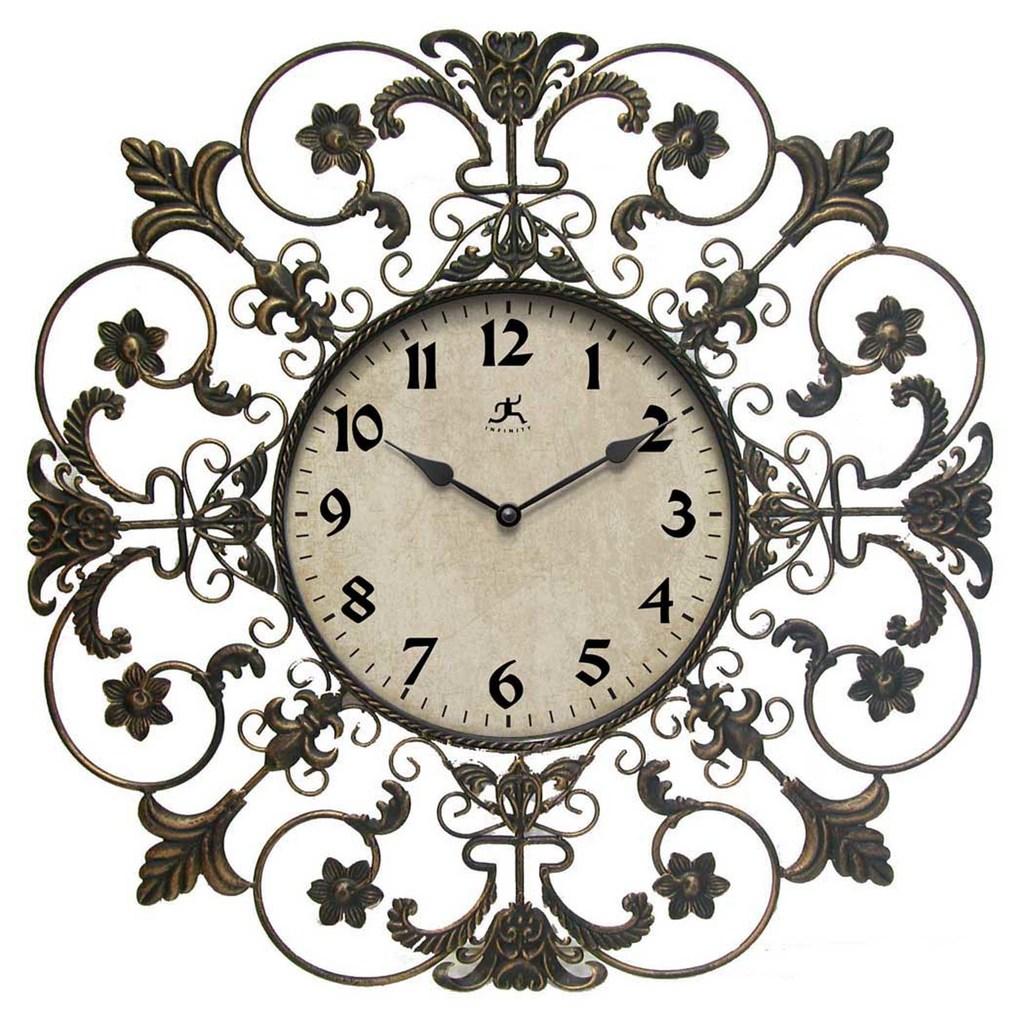What is the brand of clock?
Make the answer very short. Infinity. What time is shown?
Make the answer very short. 10:10. 